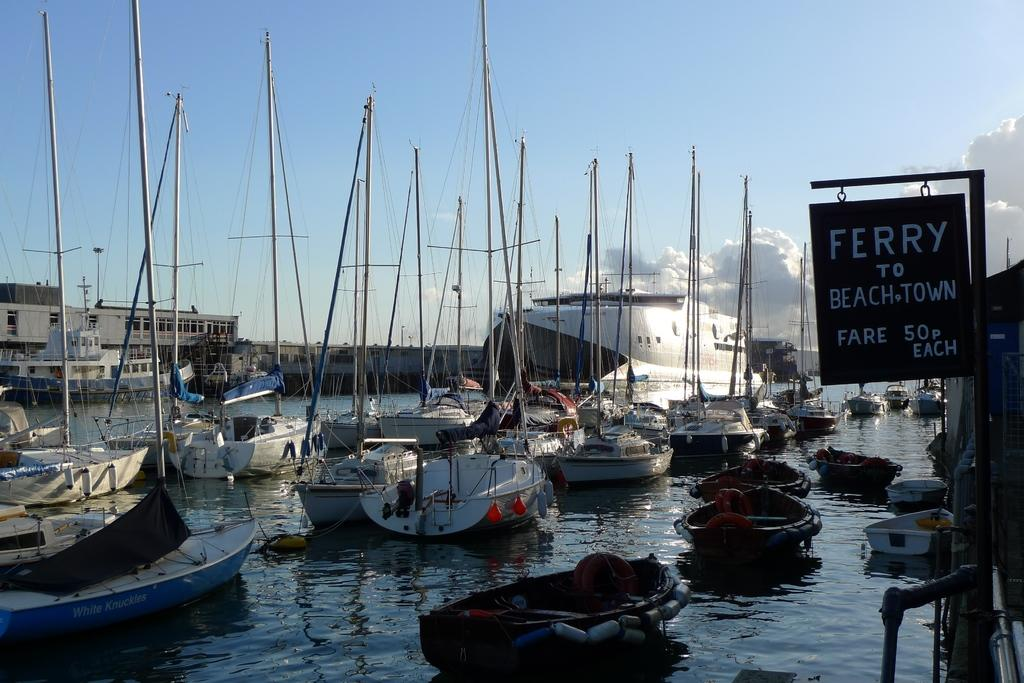<image>
Share a concise interpretation of the image provided. A sign next to the water reads ferry to beach town. 